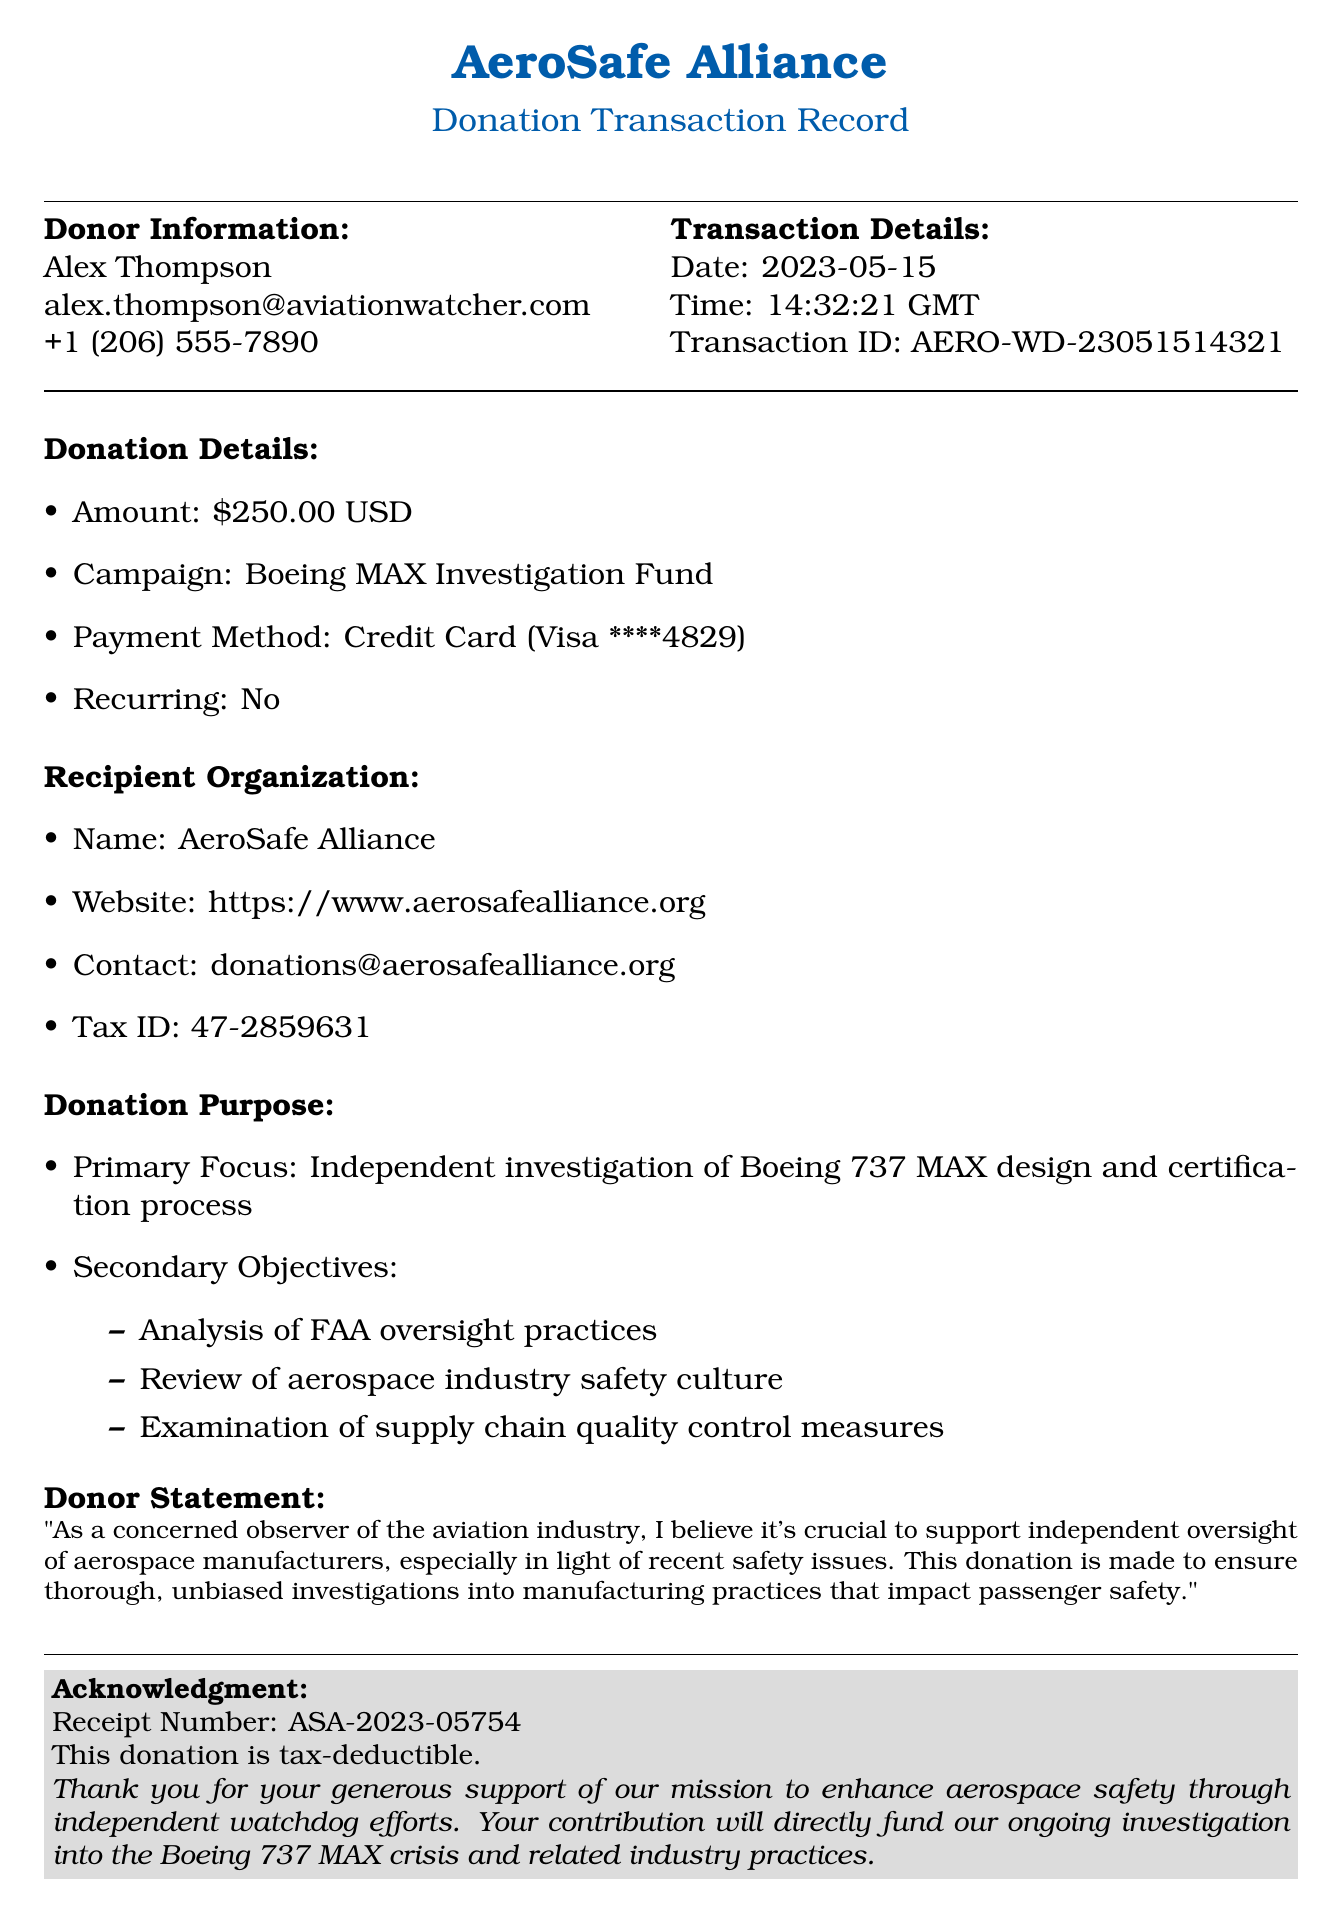What is the donation amount? The document states the donation amount as $250.00.
Answer: $250.00 Who is the donor? Alex Thompson is listed as the donor in the document.
Answer: Alex Thompson What is the tax ID of the recipient organization? The document provides the tax ID number as 47-2859631.
Answer: 47-2859631 What is the date of the transaction? The transaction date is clearly mentioned as 2023-05-15.
Answer: 2023-05-15 What is the primary focus of the donation? The document highlights the primary focus as the independent investigation of Boeing 737 MAX design and certification process.
Answer: Independent investigation of Boeing 737 MAX design and certification process What are the secondary objectives of the donation? It lists three secondary objectives: analysis of FAA oversight practices, review of aerospace industry safety culture, and examination of supply chain quality control measures.
Answer: Analysis of FAA oversight practices, review of aerospace industry safety culture, examination of supply chain quality control measures Who is the Executive Director of AeroSafe Alliance? The document names Dr. Emily Chen as the Executive Director.
Answer: Dr. Emily Chen What is the acknowledgment receipt number? The receipt number for the donation acknowledgment is indicated as ASA-2023-05754.
Answer: ASA-2023-05754 What website can you visit for the AeroSafe Alliance? The document provides the website URL as https://www.aerosafealliance.org.
Answer: https://www.aerosafealliance.org 